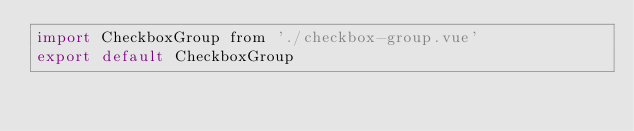<code> <loc_0><loc_0><loc_500><loc_500><_JavaScript_>import CheckboxGroup from './checkbox-group.vue'
export default CheckboxGroup
</code> 